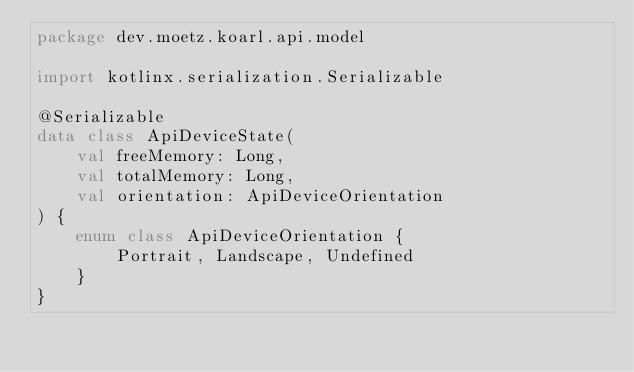Convert code to text. <code><loc_0><loc_0><loc_500><loc_500><_Kotlin_>package dev.moetz.koarl.api.model

import kotlinx.serialization.Serializable

@Serializable
data class ApiDeviceState(
    val freeMemory: Long,
    val totalMemory: Long,
    val orientation: ApiDeviceOrientation
) {
    enum class ApiDeviceOrientation {
        Portrait, Landscape, Undefined
    }
}</code> 